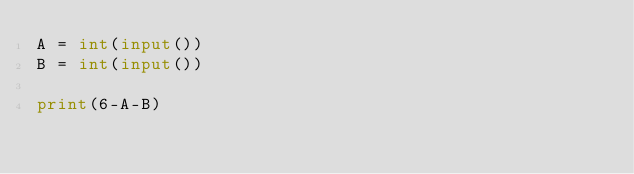Convert code to text. <code><loc_0><loc_0><loc_500><loc_500><_Python_>A = int(input())
B = int(input())

print(6-A-B)</code> 